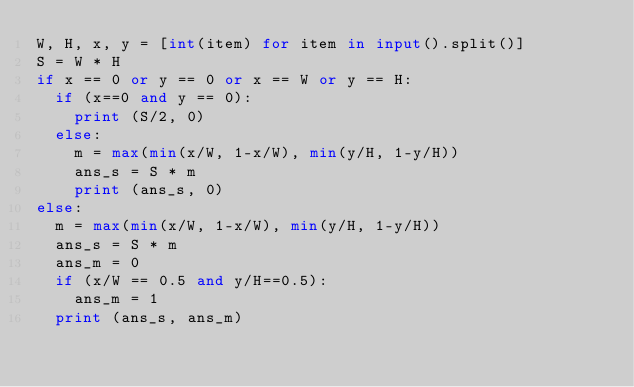Convert code to text. <code><loc_0><loc_0><loc_500><loc_500><_Python_>W, H, x, y = [int(item) for item in input().split()]
S = W * H
if x == 0 or y == 0 or x == W or y == H:
  if (x==0 and y == 0):
    print (S/2, 0)
  else:
    m = max(min(x/W, 1-x/W), min(y/H, 1-y/H))
    ans_s = S * m
    print (ans_s, 0)
else:
  m = max(min(x/W, 1-x/W), min(y/H, 1-y/H))
  ans_s = S * m
  ans_m = 0
  if (x/W == 0.5 and y/H==0.5):
    ans_m = 1
  print (ans_s, ans_m)</code> 